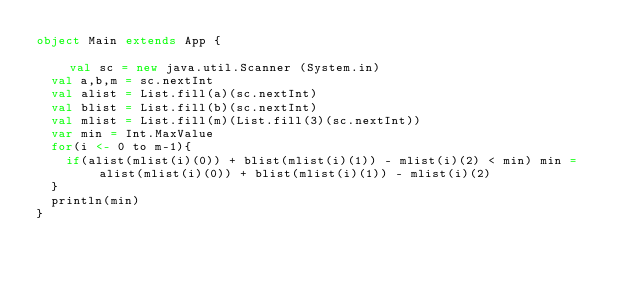Convert code to text. <code><loc_0><loc_0><loc_500><loc_500><_Scala_>object Main extends App {                                                                                                                                       val sc = new java.util.Scanner (System.in)
  val a,b,m = sc.nextInt
  val alist = List.fill(a)(sc.nextInt)
  val blist = List.fill(b)(sc.nextInt)
  val mlist = List.fill(m)(List.fill(3)(sc.nextInt))
  var min = Int.MaxValue
  for(i <- 0 to m-1){
    if(alist(mlist(i)(0)) + blist(mlist(i)(1)) - mlist(i)(2) < min) min = alist(mlist(i)(0)) + blist(mlist(i)(1)) - mlist(i)(2)
  }
  println(min)
}</code> 